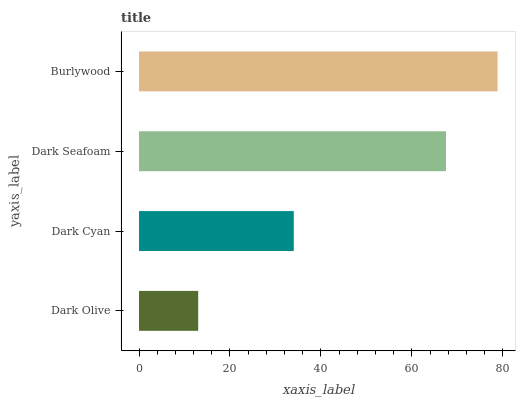Is Dark Olive the minimum?
Answer yes or no. Yes. Is Burlywood the maximum?
Answer yes or no. Yes. Is Dark Cyan the minimum?
Answer yes or no. No. Is Dark Cyan the maximum?
Answer yes or no. No. Is Dark Cyan greater than Dark Olive?
Answer yes or no. Yes. Is Dark Olive less than Dark Cyan?
Answer yes or no. Yes. Is Dark Olive greater than Dark Cyan?
Answer yes or no. No. Is Dark Cyan less than Dark Olive?
Answer yes or no. No. Is Dark Seafoam the high median?
Answer yes or no. Yes. Is Dark Cyan the low median?
Answer yes or no. Yes. Is Dark Olive the high median?
Answer yes or no. No. Is Burlywood the low median?
Answer yes or no. No. 